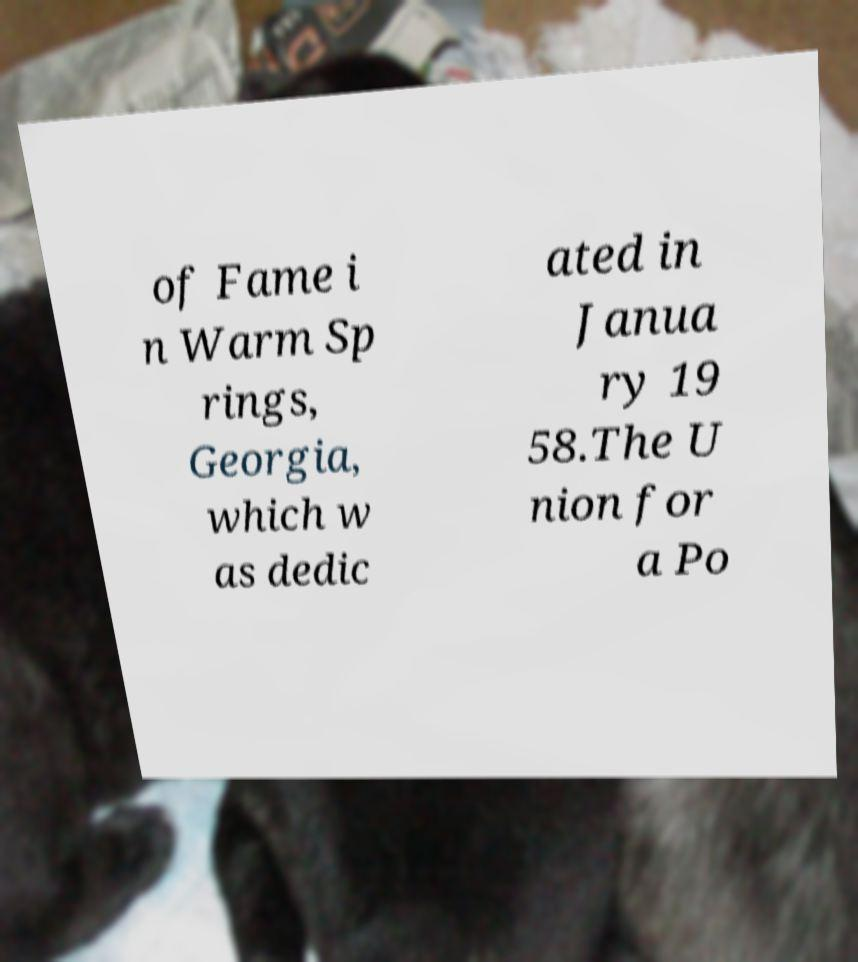There's text embedded in this image that I need extracted. Can you transcribe it verbatim? of Fame i n Warm Sp rings, Georgia, which w as dedic ated in Janua ry 19 58.The U nion for a Po 